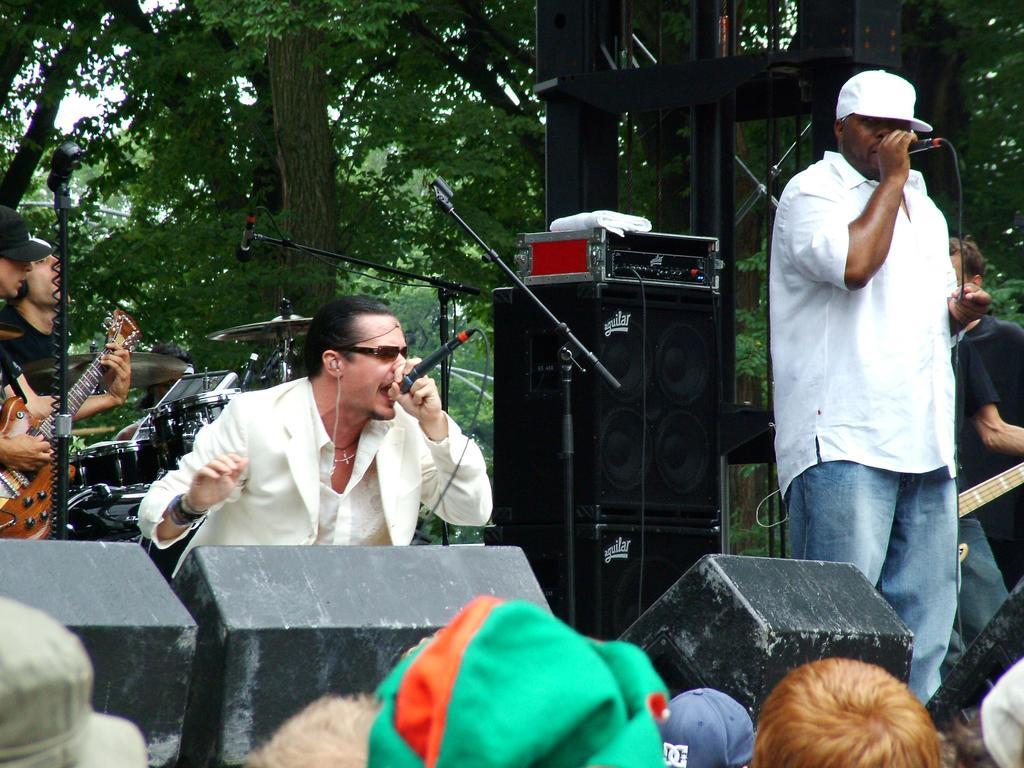How would you summarize this image in a sentence or two? In this picture we can see two persons singing on the mike. He wear a cap and he has spectacles. And on the left side we can see a person who is playing a guitar. And these are some musical instruments. And these are the trees. 